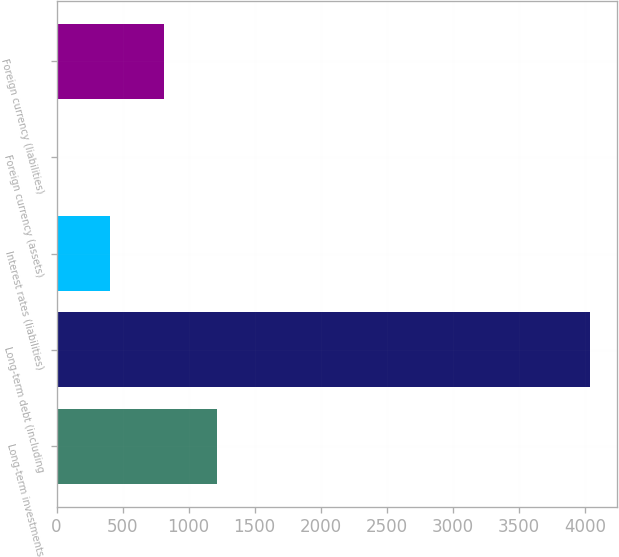<chart> <loc_0><loc_0><loc_500><loc_500><bar_chart><fcel>Long-term investments<fcel>Long-term debt (including<fcel>Interest rates (liabilities)<fcel>Foreign currency (assets)<fcel>Foreign currency (liabilities)<nl><fcel>1214.9<fcel>4039.4<fcel>407.9<fcel>4.4<fcel>811.4<nl></chart> 